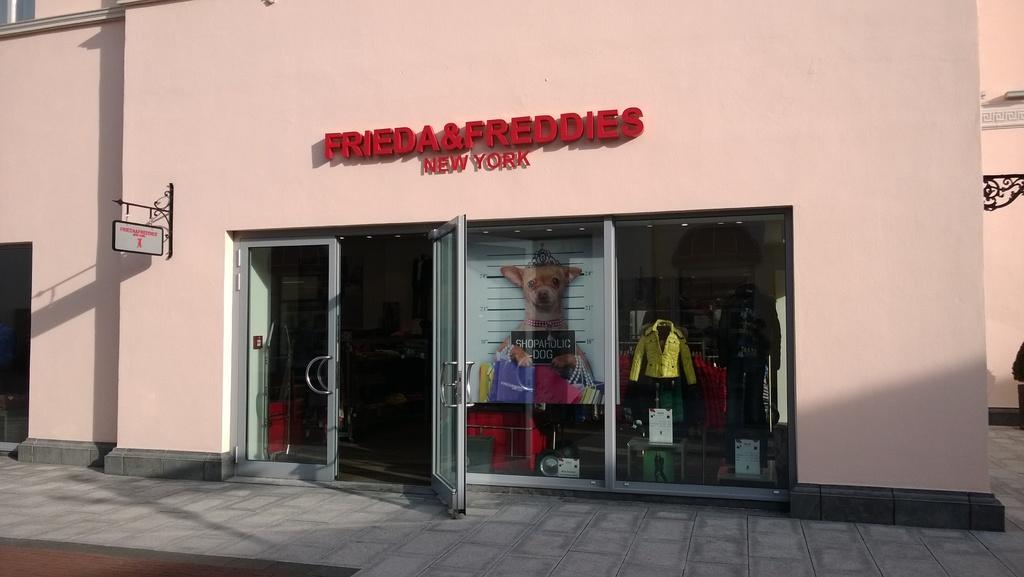Could you give a brief overview of what you see in this image? In this picture i see a building and we see text on the wall of the building and we see glass doors and we see couple of mannequins with clothes from the glass and we see a board on the left side hanging to the wall. 